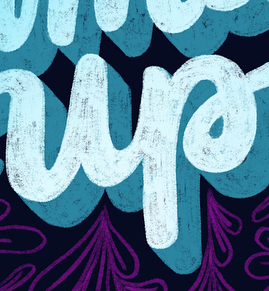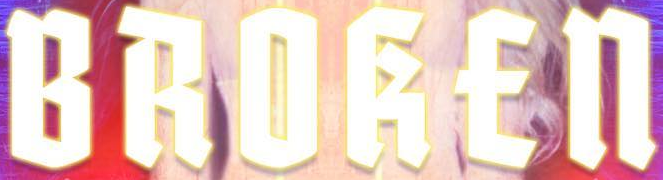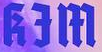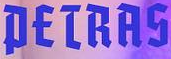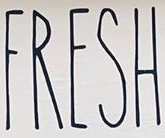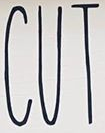What words are shown in these images in order, separated by a semicolon? up; BROKEn; kƎm; PETRAS; FRESH; CUT 